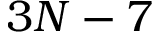<formula> <loc_0><loc_0><loc_500><loc_500>3 N - 7</formula> 